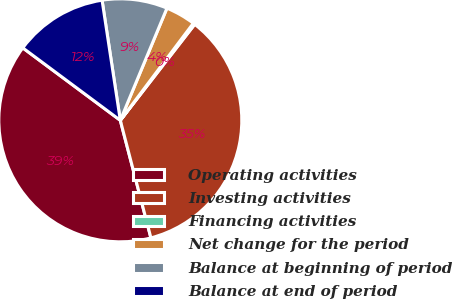<chart> <loc_0><loc_0><loc_500><loc_500><pie_chart><fcel>Operating activities<fcel>Investing activities<fcel>Financing activities<fcel>Net change for the period<fcel>Balance at beginning of period<fcel>Balance at end of period<nl><fcel>39.22%<fcel>35.45%<fcel>0.23%<fcel>3.99%<fcel>8.67%<fcel>12.43%<nl></chart> 